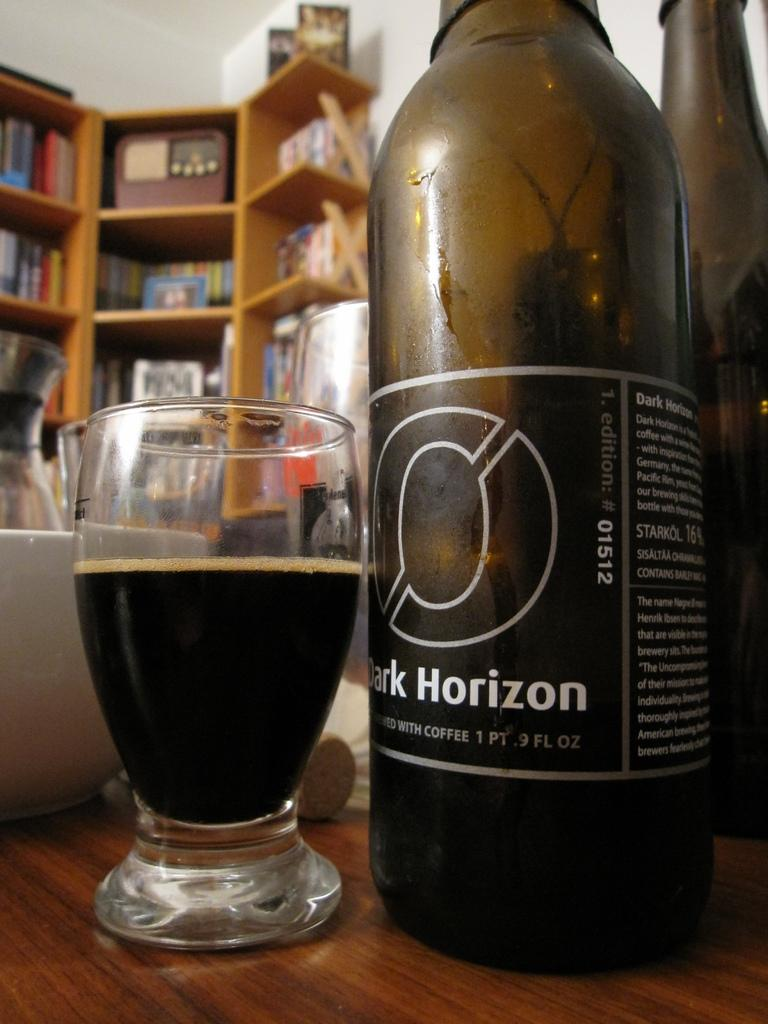<image>
Describe the image concisely. A bottle of Dark Horizon next to a filled glass. 